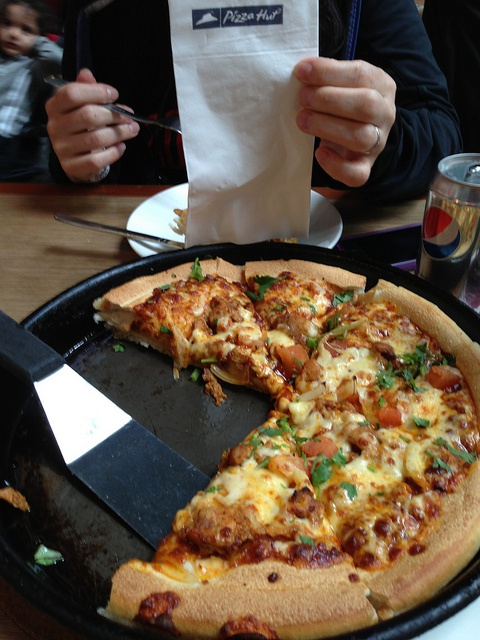Describe the objects in this image and their specific colors. I can see dining table in black, brown, tan, and maroon tones, pizza in black, brown, tan, and maroon tones, people in black, maroon, darkgray, and gray tones, knife in black, white, navy, and darkblue tones, and cup in black, gray, and maroon tones in this image. 